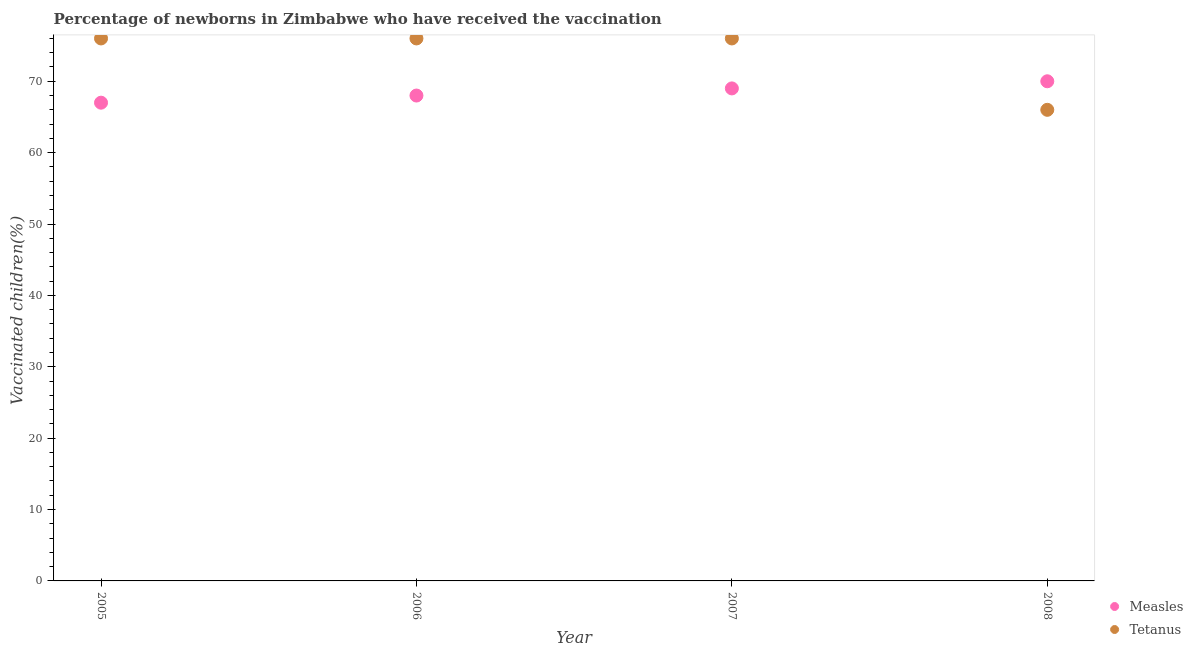How many different coloured dotlines are there?
Provide a short and direct response. 2. Is the number of dotlines equal to the number of legend labels?
Provide a short and direct response. Yes. What is the percentage of newborns who received vaccination for measles in 2005?
Provide a succinct answer. 67. Across all years, what is the maximum percentage of newborns who received vaccination for tetanus?
Make the answer very short. 76. Across all years, what is the minimum percentage of newborns who received vaccination for tetanus?
Make the answer very short. 66. In which year was the percentage of newborns who received vaccination for tetanus minimum?
Provide a short and direct response. 2008. What is the total percentage of newborns who received vaccination for tetanus in the graph?
Offer a very short reply. 294. What is the difference between the percentage of newborns who received vaccination for tetanus in 2006 and that in 2007?
Offer a very short reply. 0. What is the difference between the percentage of newborns who received vaccination for measles in 2007 and the percentage of newborns who received vaccination for tetanus in 2006?
Your answer should be compact. -7. What is the average percentage of newborns who received vaccination for measles per year?
Keep it short and to the point. 68.5. In the year 2007, what is the difference between the percentage of newborns who received vaccination for measles and percentage of newborns who received vaccination for tetanus?
Provide a succinct answer. -7. In how many years, is the percentage of newborns who received vaccination for tetanus greater than 38 %?
Make the answer very short. 4. What is the ratio of the percentage of newborns who received vaccination for tetanus in 2006 to that in 2008?
Your response must be concise. 1.15. What is the difference between the highest and the second highest percentage of newborns who received vaccination for measles?
Offer a terse response. 1. What is the difference between the highest and the lowest percentage of newborns who received vaccination for measles?
Provide a short and direct response. 3. Is the sum of the percentage of newborns who received vaccination for measles in 2007 and 2008 greater than the maximum percentage of newborns who received vaccination for tetanus across all years?
Offer a very short reply. Yes. What is the difference between two consecutive major ticks on the Y-axis?
Provide a succinct answer. 10. Are the values on the major ticks of Y-axis written in scientific E-notation?
Give a very brief answer. No. Does the graph contain any zero values?
Provide a short and direct response. No. Does the graph contain grids?
Make the answer very short. No. What is the title of the graph?
Provide a succinct answer. Percentage of newborns in Zimbabwe who have received the vaccination. Does "Adolescent fertility rate" appear as one of the legend labels in the graph?
Provide a short and direct response. No. What is the label or title of the Y-axis?
Your answer should be compact. Vaccinated children(%)
. What is the Vaccinated children(%)
 in Measles in 2005?
Provide a succinct answer. 67. What is the Vaccinated children(%)
 in Tetanus in 2005?
Offer a terse response. 76. What is the Vaccinated children(%)
 in Measles in 2006?
Ensure brevity in your answer.  68. What is the Vaccinated children(%)
 in Tetanus in 2006?
Your response must be concise. 76. What is the Vaccinated children(%)
 in Measles in 2008?
Ensure brevity in your answer.  70. What is the Vaccinated children(%)
 in Tetanus in 2008?
Your answer should be very brief. 66. Across all years, what is the maximum Vaccinated children(%)
 of Measles?
Provide a succinct answer. 70. What is the total Vaccinated children(%)
 of Measles in the graph?
Offer a terse response. 274. What is the total Vaccinated children(%)
 of Tetanus in the graph?
Your response must be concise. 294. What is the difference between the Vaccinated children(%)
 in Measles in 2005 and that in 2007?
Offer a terse response. -2. What is the difference between the Vaccinated children(%)
 of Tetanus in 2005 and that in 2007?
Your answer should be compact. 0. What is the difference between the Vaccinated children(%)
 in Measles in 2005 and that in 2008?
Provide a succinct answer. -3. What is the difference between the Vaccinated children(%)
 of Tetanus in 2005 and that in 2008?
Provide a short and direct response. 10. What is the difference between the Vaccinated children(%)
 in Measles in 2006 and that in 2007?
Make the answer very short. -1. What is the difference between the Vaccinated children(%)
 of Measles in 2006 and that in 2008?
Offer a very short reply. -2. What is the difference between the Vaccinated children(%)
 of Measles in 2005 and the Vaccinated children(%)
 of Tetanus in 2006?
Make the answer very short. -9. What is the difference between the Vaccinated children(%)
 of Measles in 2005 and the Vaccinated children(%)
 of Tetanus in 2007?
Your answer should be very brief. -9. What is the difference between the Vaccinated children(%)
 of Measles in 2005 and the Vaccinated children(%)
 of Tetanus in 2008?
Provide a succinct answer. 1. What is the difference between the Vaccinated children(%)
 of Measles in 2006 and the Vaccinated children(%)
 of Tetanus in 2007?
Your response must be concise. -8. What is the difference between the Vaccinated children(%)
 in Measles in 2006 and the Vaccinated children(%)
 in Tetanus in 2008?
Provide a succinct answer. 2. What is the average Vaccinated children(%)
 of Measles per year?
Ensure brevity in your answer.  68.5. What is the average Vaccinated children(%)
 in Tetanus per year?
Provide a short and direct response. 73.5. In the year 2007, what is the difference between the Vaccinated children(%)
 of Measles and Vaccinated children(%)
 of Tetanus?
Make the answer very short. -7. What is the ratio of the Vaccinated children(%)
 in Measles in 2005 to that in 2006?
Give a very brief answer. 0.99. What is the ratio of the Vaccinated children(%)
 in Measles in 2005 to that in 2007?
Your response must be concise. 0.97. What is the ratio of the Vaccinated children(%)
 in Measles in 2005 to that in 2008?
Your answer should be very brief. 0.96. What is the ratio of the Vaccinated children(%)
 in Tetanus in 2005 to that in 2008?
Keep it short and to the point. 1.15. What is the ratio of the Vaccinated children(%)
 in Measles in 2006 to that in 2007?
Provide a short and direct response. 0.99. What is the ratio of the Vaccinated children(%)
 in Tetanus in 2006 to that in 2007?
Your answer should be very brief. 1. What is the ratio of the Vaccinated children(%)
 of Measles in 2006 to that in 2008?
Your answer should be compact. 0.97. What is the ratio of the Vaccinated children(%)
 in Tetanus in 2006 to that in 2008?
Your answer should be very brief. 1.15. What is the ratio of the Vaccinated children(%)
 in Measles in 2007 to that in 2008?
Ensure brevity in your answer.  0.99. What is the ratio of the Vaccinated children(%)
 of Tetanus in 2007 to that in 2008?
Your answer should be very brief. 1.15. What is the difference between the highest and the lowest Vaccinated children(%)
 in Measles?
Give a very brief answer. 3. 